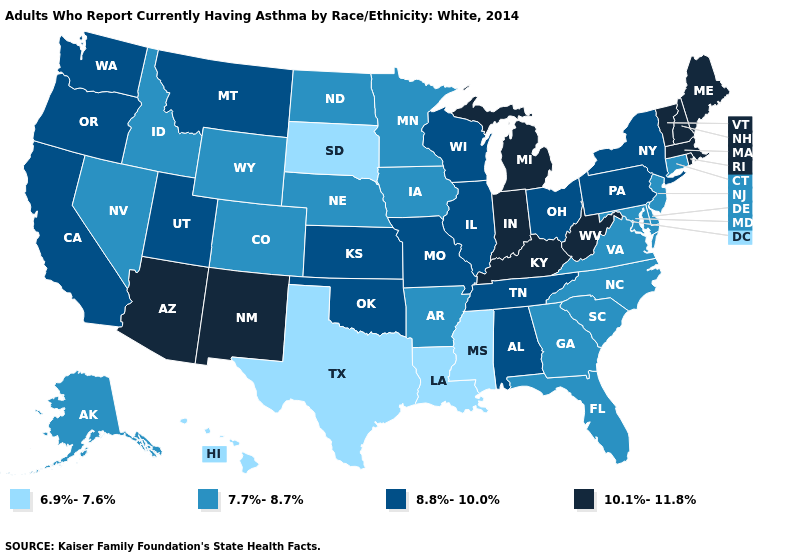Name the states that have a value in the range 6.9%-7.6%?
Keep it brief. Hawaii, Louisiana, Mississippi, South Dakota, Texas. Does West Virginia have the highest value in the South?
Give a very brief answer. Yes. Does Maryland have a higher value than Hawaii?
Write a very short answer. Yes. Name the states that have a value in the range 10.1%-11.8%?
Keep it brief. Arizona, Indiana, Kentucky, Maine, Massachusetts, Michigan, New Hampshire, New Mexico, Rhode Island, Vermont, West Virginia. Name the states that have a value in the range 7.7%-8.7%?
Quick response, please. Alaska, Arkansas, Colorado, Connecticut, Delaware, Florida, Georgia, Idaho, Iowa, Maryland, Minnesota, Nebraska, Nevada, New Jersey, North Carolina, North Dakota, South Carolina, Virginia, Wyoming. Name the states that have a value in the range 8.8%-10.0%?
Write a very short answer. Alabama, California, Illinois, Kansas, Missouri, Montana, New York, Ohio, Oklahoma, Oregon, Pennsylvania, Tennessee, Utah, Washington, Wisconsin. Does the first symbol in the legend represent the smallest category?
Quick response, please. Yes. What is the value of Illinois?
Write a very short answer. 8.8%-10.0%. Does South Dakota have the lowest value in the USA?
Keep it brief. Yes. Which states have the lowest value in the USA?
Keep it brief. Hawaii, Louisiana, Mississippi, South Dakota, Texas. Name the states that have a value in the range 10.1%-11.8%?
Concise answer only. Arizona, Indiana, Kentucky, Maine, Massachusetts, Michigan, New Hampshire, New Mexico, Rhode Island, Vermont, West Virginia. What is the highest value in the MidWest ?
Be succinct. 10.1%-11.8%. Name the states that have a value in the range 6.9%-7.6%?
Quick response, please. Hawaii, Louisiana, Mississippi, South Dakota, Texas. Does Alabama have the same value as Oklahoma?
Be succinct. Yes. What is the value of Colorado?
Keep it brief. 7.7%-8.7%. 